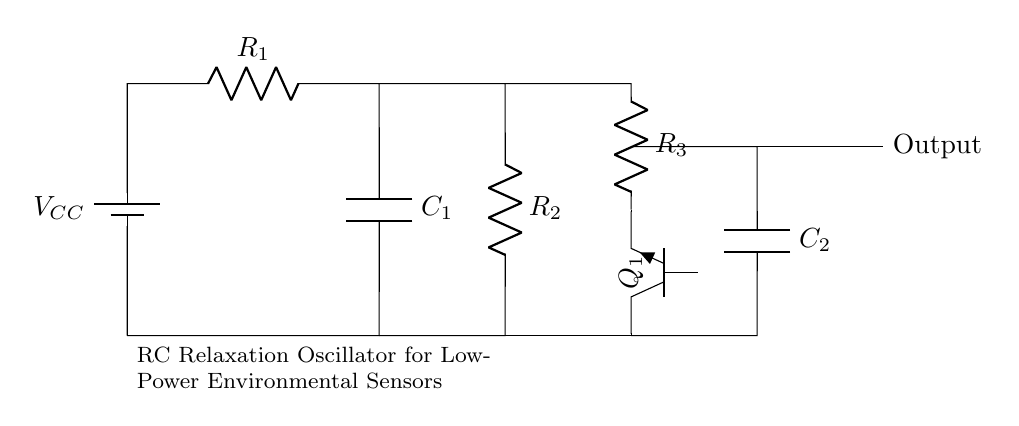What is the power source used in this circuit? The power source is a battery, indicated by the battery symbol labeled as V_CC.
Answer: battery What is the function of capacitor C1 in this oscillator? Capacitor C1 charges and discharges, contributing to the timing mechanism of the oscillator. It works with the resistors to create a time delay, defining the oscillation frequency.
Answer: timing What are the values of resistors used in the circuit? The circuit contains three resistors R1, R2, and R3, but their specific values are not provided in the diagram. They can be selected based on the desired oscillation frequency.
Answer: unspecified Why is a transistor used in this circuit? The transistor acts as a switch, controlling the charging and discharging of the capacitors, which allows for oscillation and stability in the output signal.
Answer: switching How many capacitors are present in the circuit? There are two capacitors shown in the circuit diagram, C1 and C2, both contributing to the operation of the oscillator.
Answer: two 